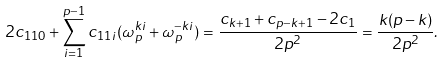<formula> <loc_0><loc_0><loc_500><loc_500>2 c _ { 1 1 0 } + \sum _ { i = 1 } ^ { p - 1 } c _ { 1 1 i } ( \omega _ { p } ^ { k i } + \omega _ { p } ^ { - k i } ) = \frac { c _ { k + 1 } + c _ { p - k + 1 } - 2 c _ { 1 } } { 2 p ^ { 2 } } = \frac { k ( p - k ) } { 2 p ^ { 2 } } .</formula> 